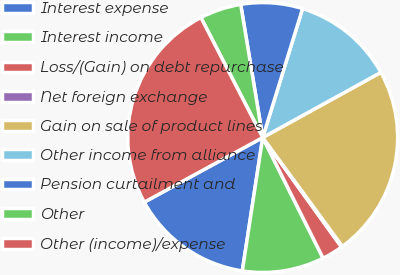Convert chart. <chart><loc_0><loc_0><loc_500><loc_500><pie_chart><fcel>Interest expense<fcel>Interest income<fcel>Loss/(Gain) on debt repurchase<fcel>Net foreign exchange<fcel>Gain on sale of product lines<fcel>Other income from alliance<fcel>Pension curtailment and<fcel>Other<fcel>Other (income)/expense<nl><fcel>14.63%<fcel>9.8%<fcel>2.54%<fcel>0.13%<fcel>22.96%<fcel>12.21%<fcel>7.38%<fcel>4.96%<fcel>25.38%<nl></chart> 